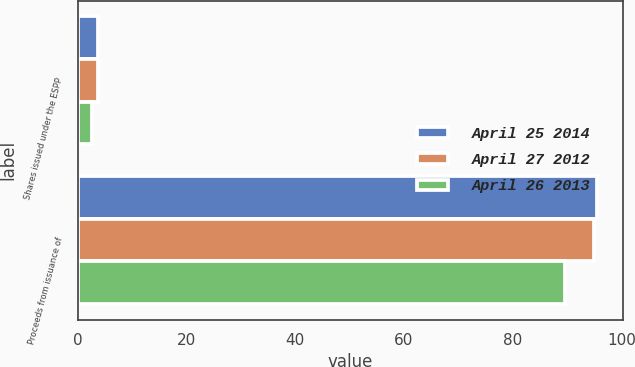Convert chart to OTSL. <chart><loc_0><loc_0><loc_500><loc_500><stacked_bar_chart><ecel><fcel>Shares issued under the ESPP<fcel>Proceeds from issuance of<nl><fcel>April 25 2014<fcel>3.8<fcel>95.5<nl><fcel>April 27 2012<fcel>3.8<fcel>95<nl><fcel>April 26 2013<fcel>2.6<fcel>89.6<nl></chart> 